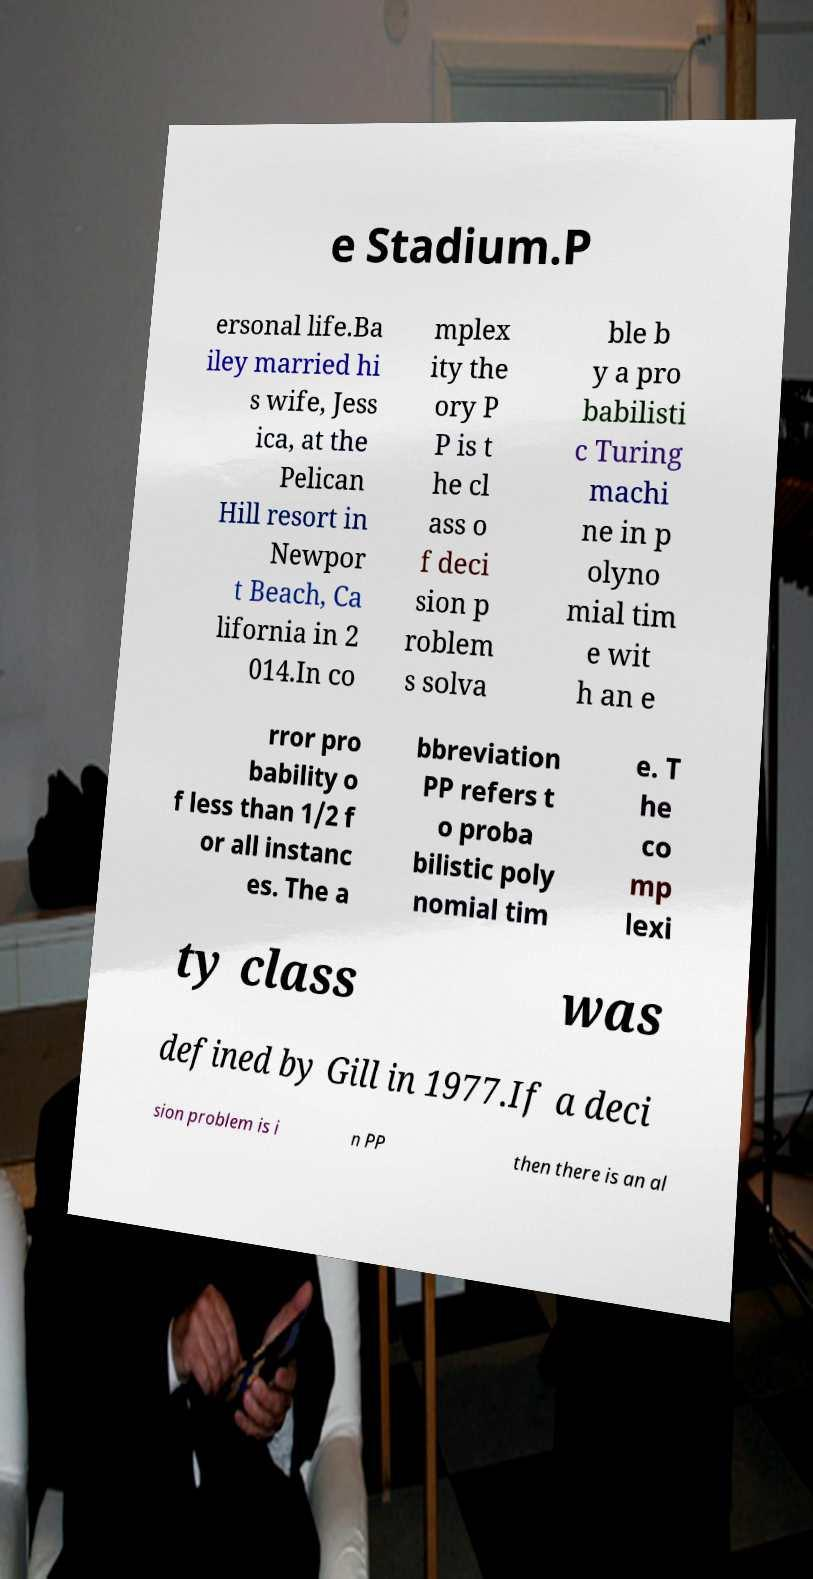Can you read and provide the text displayed in the image?This photo seems to have some interesting text. Can you extract and type it out for me? e Stadium.P ersonal life.Ba iley married hi s wife, Jess ica, at the Pelican Hill resort in Newpor t Beach, Ca lifornia in 2 014.In co mplex ity the ory P P is t he cl ass o f deci sion p roblem s solva ble b y a pro babilisti c Turing machi ne in p olyno mial tim e wit h an e rror pro bability o f less than 1/2 f or all instanc es. The a bbreviation PP refers t o proba bilistic poly nomial tim e. T he co mp lexi ty class was defined by Gill in 1977.If a deci sion problem is i n PP then there is an al 